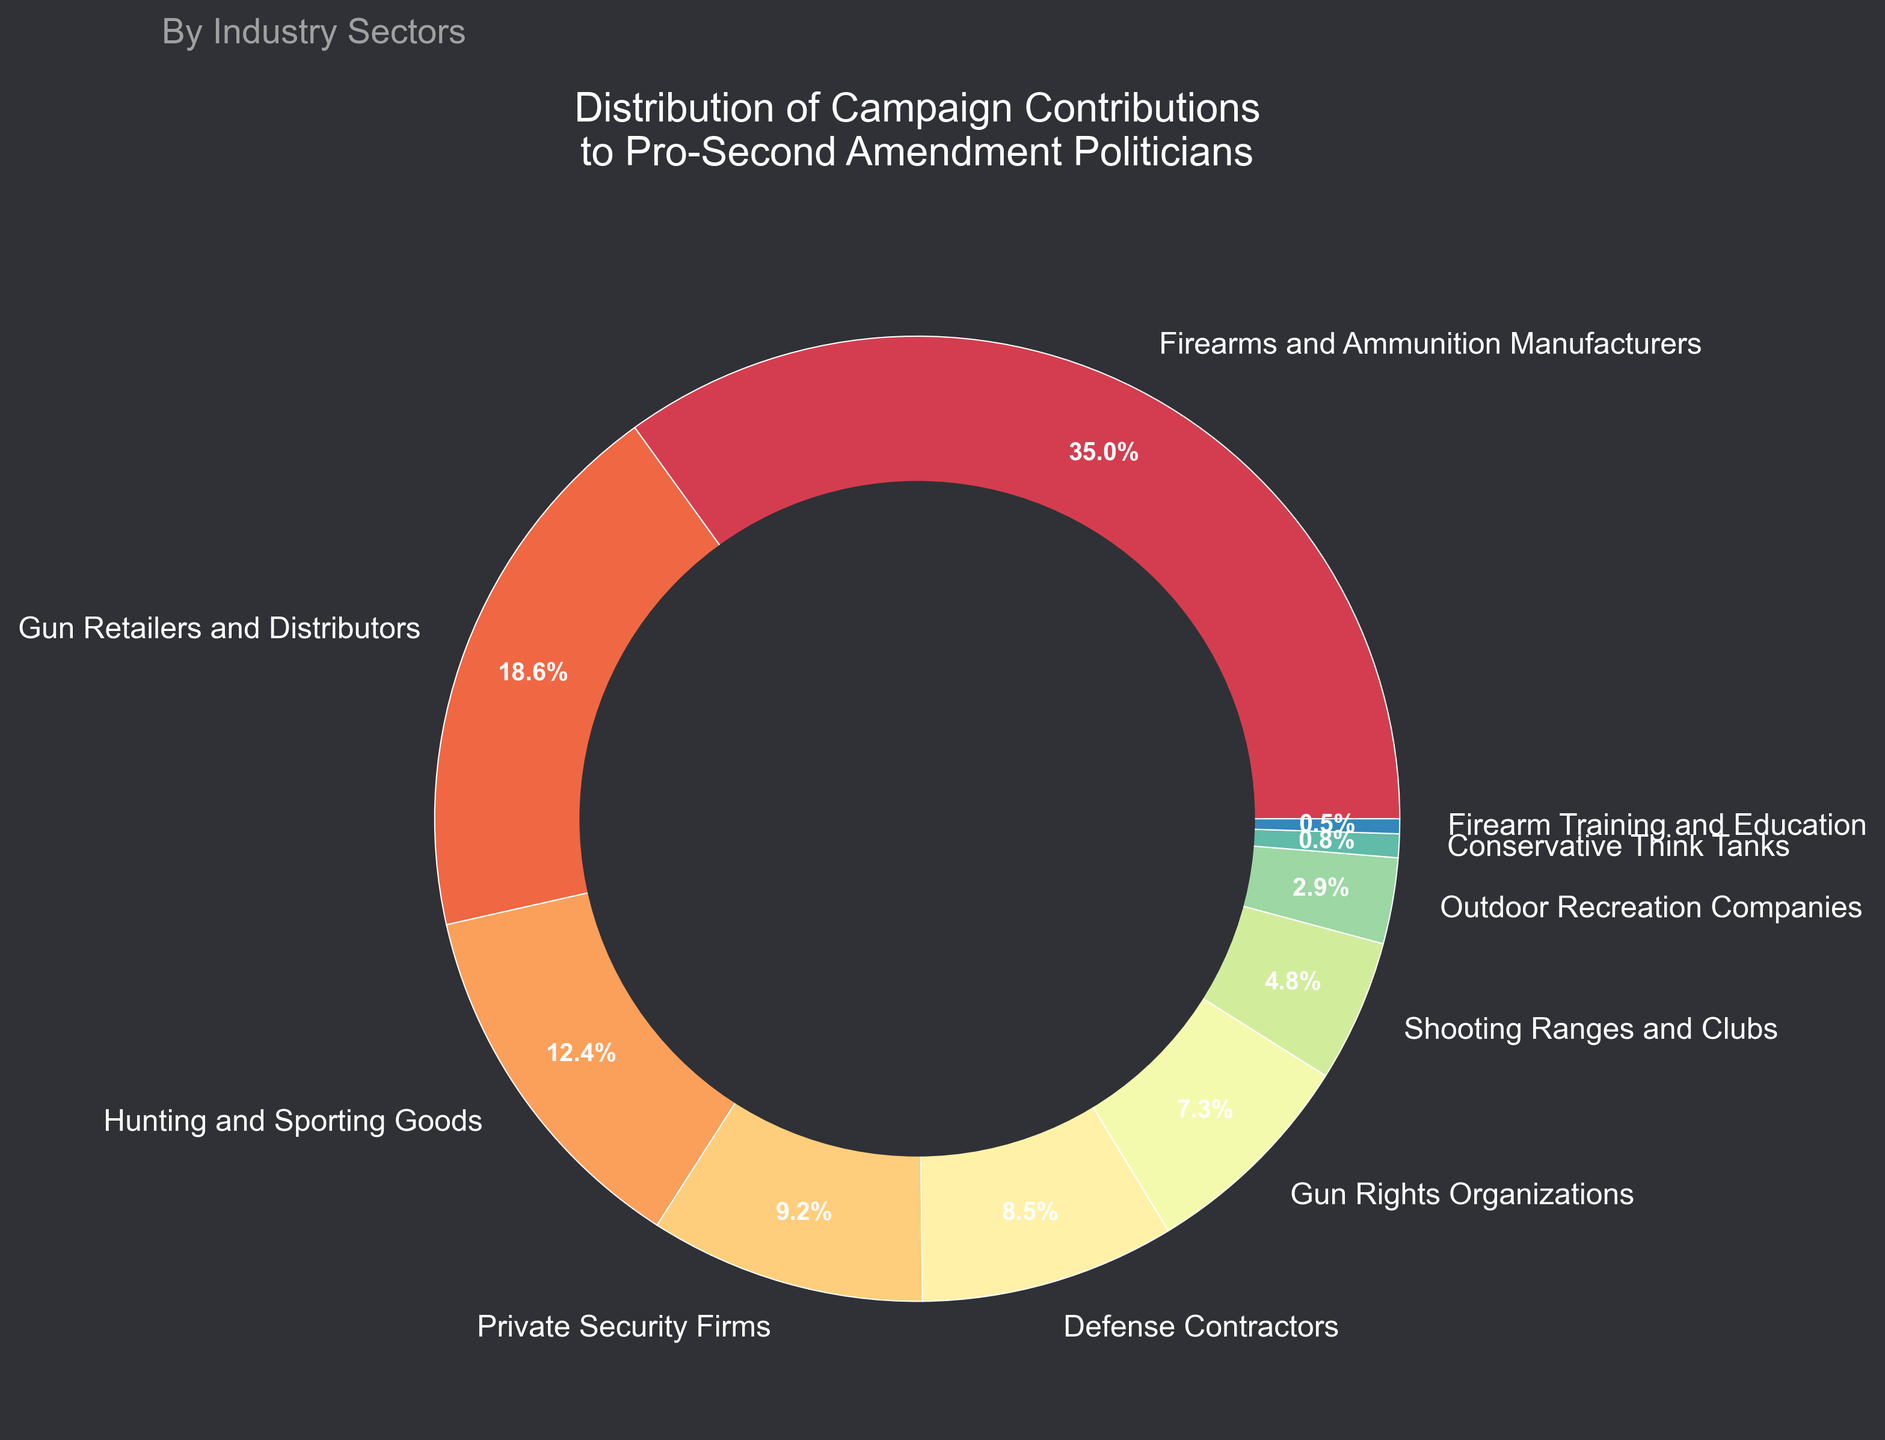What industry sector contributes the most to pro-Second Amendment politicians? The largest segment of the pie chart represents Firearms and Ammunition Manufacturers. The percentage for this sector is 35.2%, which is the highest among all the sectors presented.
Answer: Firearms and Ammunition Manufacturers How much more do Gun Retailers and Distributors contribute compared to Private Security Firms? Gun Retailers and Distributors contribute 18.7%, while Private Security Firms contribute 9.3%. The difference is 18.7% - 9.3% = 9.4%.
Answer: 9.4% Do Defense Contractors and Gun Rights Organizations together contribute more than Firearms and Ammunition Manufacturers alone? Defense Contractors contribute 8.6% and Gun Rights Organizations contribute 7.4%. Together, they contribute 8.6% + 7.4% = 16%. Firearms and Ammunition Manufacturers contribute 35.2%, which is greater than 16%.
Answer: No What is the combined contribution percentage of the smallest three industry sectors? The percentages for the smallest three sectors are Firearm Training and Education (0.5%), Conservative Think Tanks (0.8%), and Outdoor Recreation Companies (2.9%). Their combined contribution is 0.5% + 0.8% + 2.9% = 4.2%.
Answer: 4.2% Which sector has a slightly smaller contribution than Hunting and Sporting Goods? Hunting and Sporting Goods contribute 12.5%. The next largest sector is Private Security Firms, which contribute 9.3%.
Answer: Private Security Firms What sectors are represented by the two smallest segments in the pie chart? The two smallest segments in the pie chart represent Firearm Training and Education (0.5%) and Conservative Think Tanks (0.8%).
Answer: Firearm Training and Education and Conservative Think Tanks If Gun Retailers and Distributors and Shooting Ranges and Clubs combined their contributions, what percentage would they hold? Gun Retailers and Distributors contribute 18.7%, and Shooting Ranges and Clubs contribute 4.8%. Their combined contribution would be 18.7% + 4.8% = 23.5%.
Answer: 23.5% Between Outdoor Recreation Companies and Shooting Ranges and Clubs, which has a larger share and by how much? Shooting Ranges and Clubs contribute 4.8%, while Outdoor Recreation Companies contribute 2.9%. The difference is 4.8% - 2.9% = 1.9%.
Answer: Shooting Ranges and Clubs by 1.9% Is the combined contribution of Hunting and Sporting Goods plus Defense Contractors more than 20%? Hunting and Sporting Goods contribute 12.5%, and Defense Contractors contribute 8.6%. Combined, they contribute 12.5% + 8.6% = 21.1%, which is more than 20%.
Answer: Yes What is the visual characteristic used to distinguish between different industry sectors in the pie chart? The pie chart uses different colors for each industry sector, with a custom color palette. Each sector is also labeled with the industry name and percentage contribution.
Answer: Different colors 